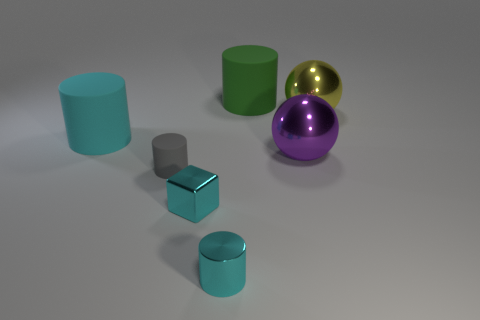How many matte things have the same color as the metal cube?
Give a very brief answer. 1. What is the color of the large metal ball in front of the large rubber object that is left of the large green cylinder?
Your response must be concise. Purple. Are there an equal number of cyan rubber things that are in front of the cyan metallic block and large purple metal objects left of the large purple ball?
Ensure brevity in your answer.  Yes. Are the big cylinder in front of the large green rubber object and the green thing made of the same material?
Ensure brevity in your answer.  Yes. The rubber cylinder that is behind the gray rubber thing and to the left of the metal cube is what color?
Your response must be concise. Cyan. There is a big matte cylinder left of the green matte cylinder; what number of spheres are behind it?
Offer a very short reply. 1. There is a small gray object that is the same shape as the big cyan object; what material is it?
Your answer should be very brief. Rubber. The tiny rubber object has what color?
Provide a succinct answer. Gray. How many things are either large purple matte blocks or small cyan metallic blocks?
Make the answer very short. 1. There is a cyan object on the left side of the matte cylinder that is in front of the big cyan cylinder; what is its shape?
Provide a short and direct response. Cylinder. 